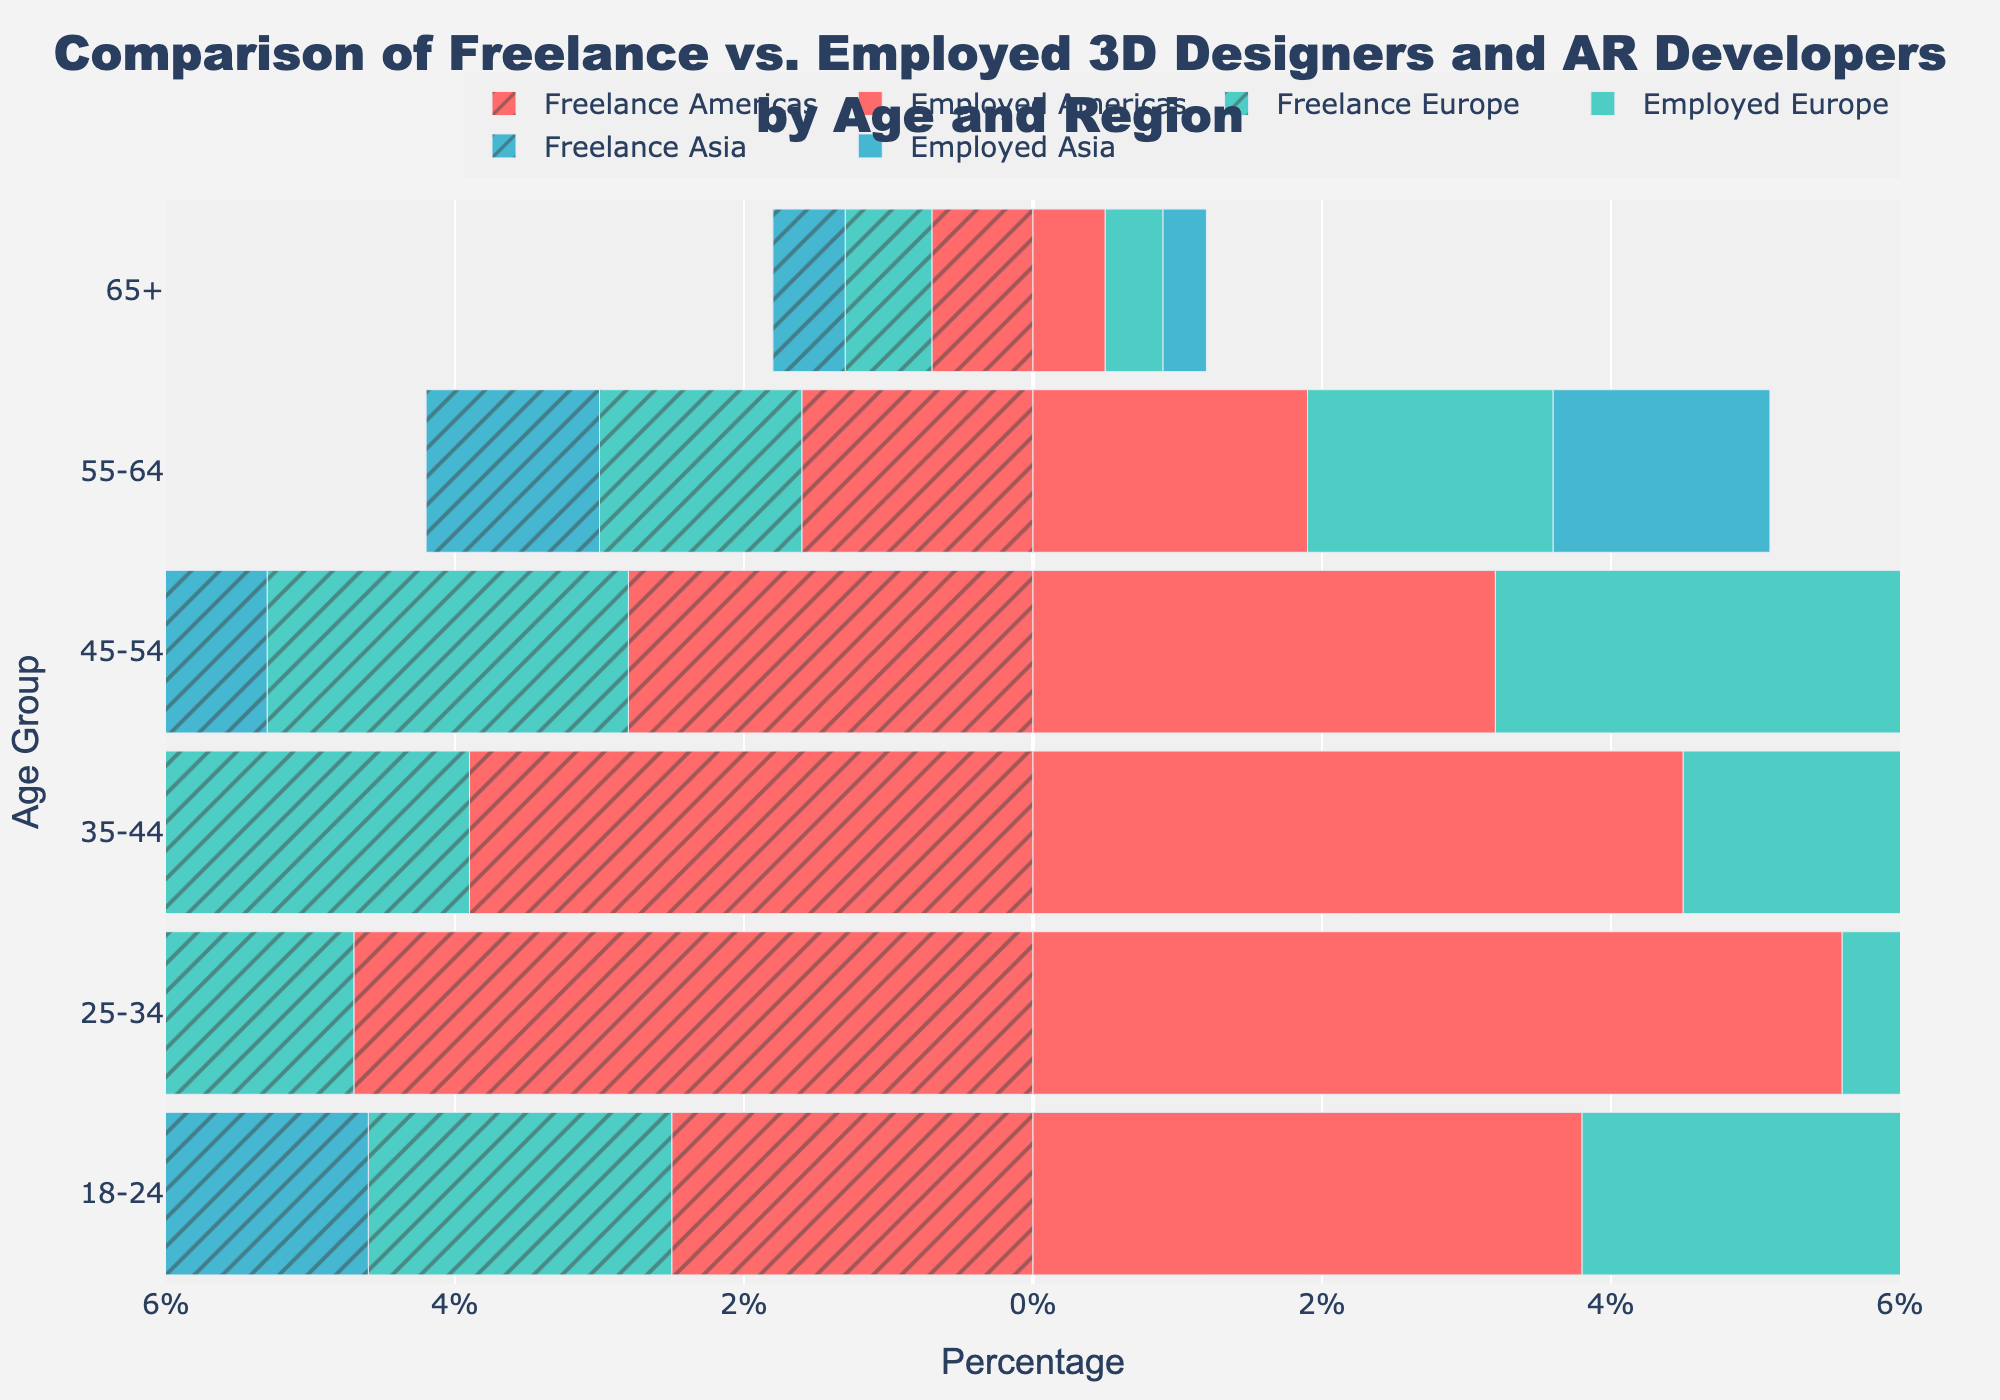What is the title of the plot? The title is located at the top center of the plot. It reads "Comparison of Freelance vs. Employed 3D Designers and AR Developers by Age and Region", which provides context for the figure.
Answer: Comparison of Freelance vs. Employed 3D Designers and AR Developers by Age and Region What does the x-axis represent? The x-axis label is visible on the bottom of the plot. It represents "Percentage" which shows the proportion of each age group engaged in freelance and employed positions.
Answer: Percentage How many age groups are displayed on the y-axis? The y-axis lists the different age group categories, which can be counted directly. There are six age groups: "18-24", "25-34", "35-44", "45-54", "55-64", and "65+".
Answer: 6 Which region shows the highest percentage of freelance 3D designers and AR developers in the 25-34 age group? By observing the bars for the 25-34 age group, the highest negative value (representing freelancers) on the left side is for the Americas region.
Answer: Americas What is the difference in percentage between freelance and employed 3D designers and AR developers aged 25-34 in Asia? Look at the bars for Asia in the 25-34 age group. Freelance is at 3.9% and employed is at 4.8%. The difference is 4.8% - 3.9%.
Answer: 0.9% In which age group is the percentage of employed 3D designers and AR developers the lowest for Europe? The employed bars for Europe can be observed, and the lowest one in height corresponds to the 65+ age group with 0.4%.
Answer: 65+ How does the percentage of freelance 3D designers and AR developers in the Americas for the 45-54 age group compare to those in Europe? Examine the bars for the 45-54 age group. Freelancers in the Americas have a percentage of 2.8%, while those in Europe have 2.5%. 2.8% is slightly higher than 2.5%.
Answer: Americas What is the overall trend of employment (both freelance and employed) as age increases across all regions? Observe the pattern from left to right across the age groups. Generally, both freelance and employed percentages decrease as age increases.
Answer: Decrease How evenly distributed is the percentage of freelance 3D designers and AR developers across all regions in the 35-44 age group? Check the bars for the 35-44 age group across the three regions. Freelancers in the Americas are at 3.9%, Europe 3.6%, and Asia 3.3%. The values are relatively close, indicating an even distribution.
Answer: Evenly distributed In which region is there the smallest gap between freelance and employed percentages in the 55-64 age group? Compare the bars for freelancers and employed in the 55-64 age group across regions. The smallest gap is in Asia, with a difference of 0.3% (1.5% for employed and 1.2% for freelance).
Answer: Asia 